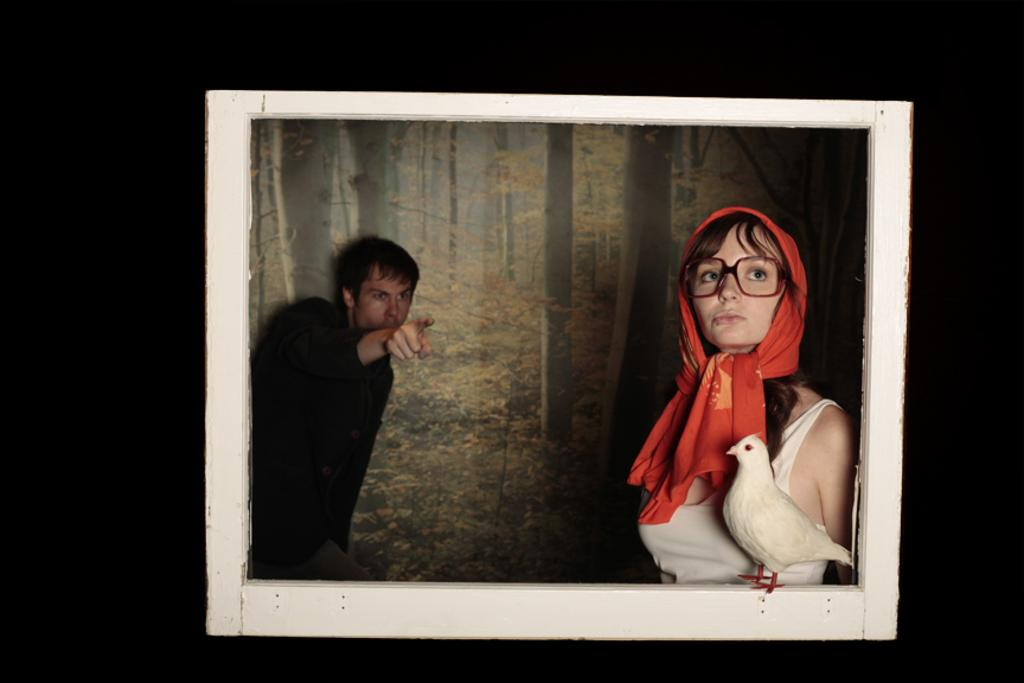What is the main object in the center of the image? There is a photo frame in the center of the image. How many people are in the image? There are two persons in the image. What type of animal is present in the image? There is a bird in the image. What type of vegetation can be seen in the image? There are trees in the image. How would you describe the lighting in the image? The background of the image is dark. What type of brake system is visible in the image? There is no brake system present in the image. What type of spacecraft can be seen in the image? There is no spacecraft present in the image. 